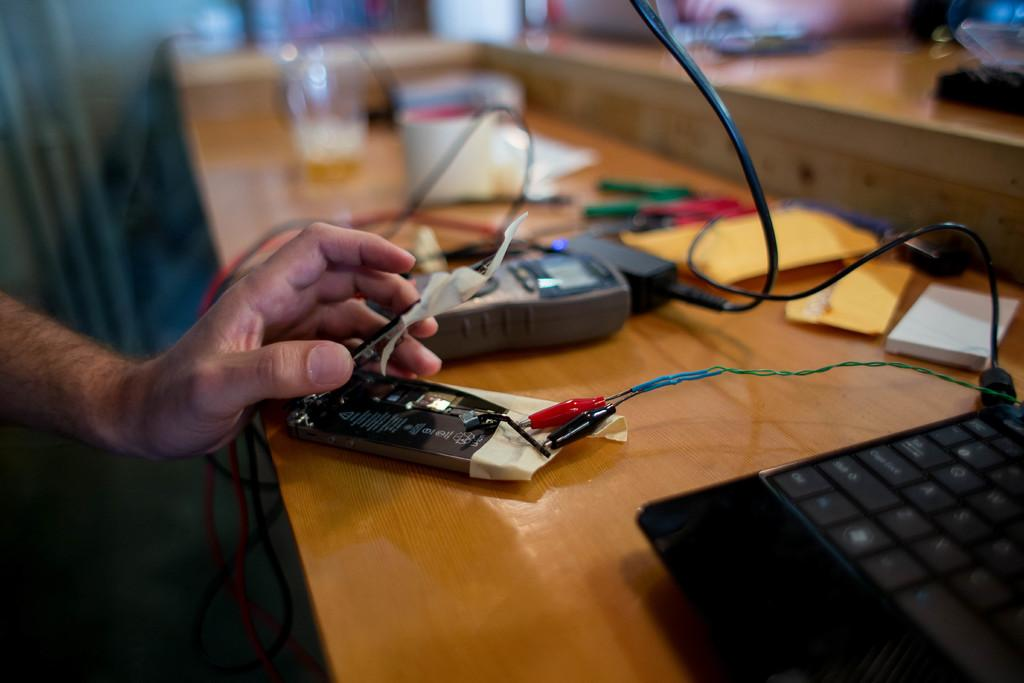What piece of furniture is present in the image? There is a table in the image. What electronic device is on the table? There is a laptop on the table. Whose hand is visible in the image? A person's hand is visible in the image. What else can be seen on the table besides the laptop? There are objects on the table. Can you tell me where the receipt is located in the image? There is no receipt present in the image. What color is the balloon on the table in the image? There is no balloon present in the image. 